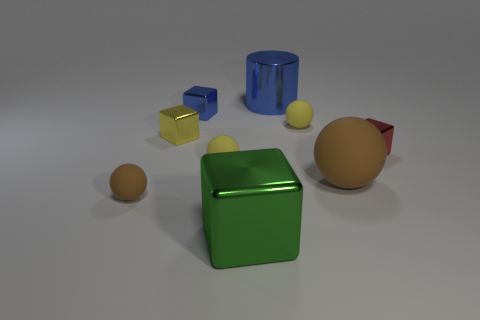How does the lighting in the image influence the perception of the objects? The overhead lighting creates soft shadows and highlights on the objects, enhancing their three-dimensional form. It allows us to better comprehend the shapes, textures, and material properties, like the sheen on the blue and green cubes and the more diffused light on the matte surfaces of the spherical objects. Does the shadowing provide any information about the light source? Yes, the direction and length of the shadows suggest a single, diffused light source positioned above and slightly to the right of the objects. The soft edges of the shadows indicate that the light source is not extremely close to the objects, which provides a gentle illumination. 